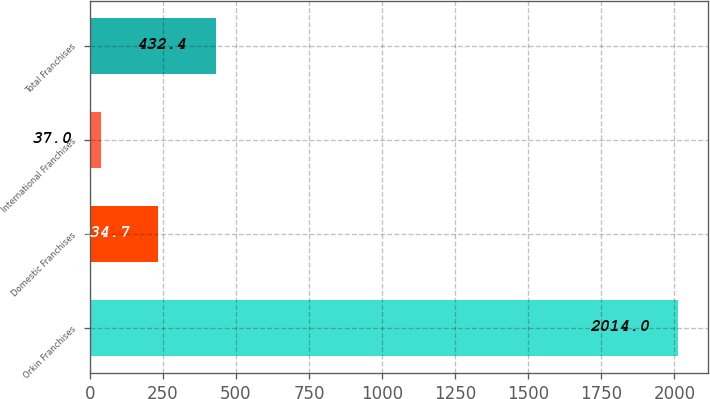<chart> <loc_0><loc_0><loc_500><loc_500><bar_chart><fcel>Orkin Franchises<fcel>Domestic Franchises<fcel>International Franchises<fcel>Total Franchises<nl><fcel>2014<fcel>234.7<fcel>37<fcel>432.4<nl></chart> 